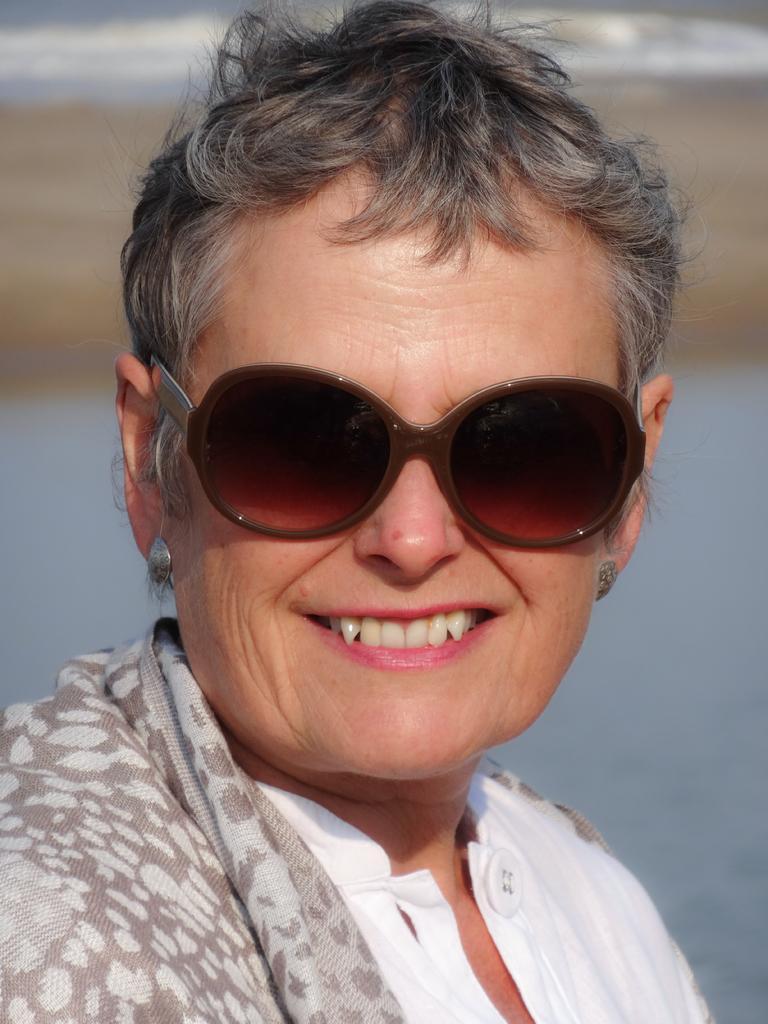Please provide a concise description of this image. In this picture I can observe a woman. She is wearing white color dress and spectacles. Woman is smiling. The background is blurred. I can observe some water behind her. 